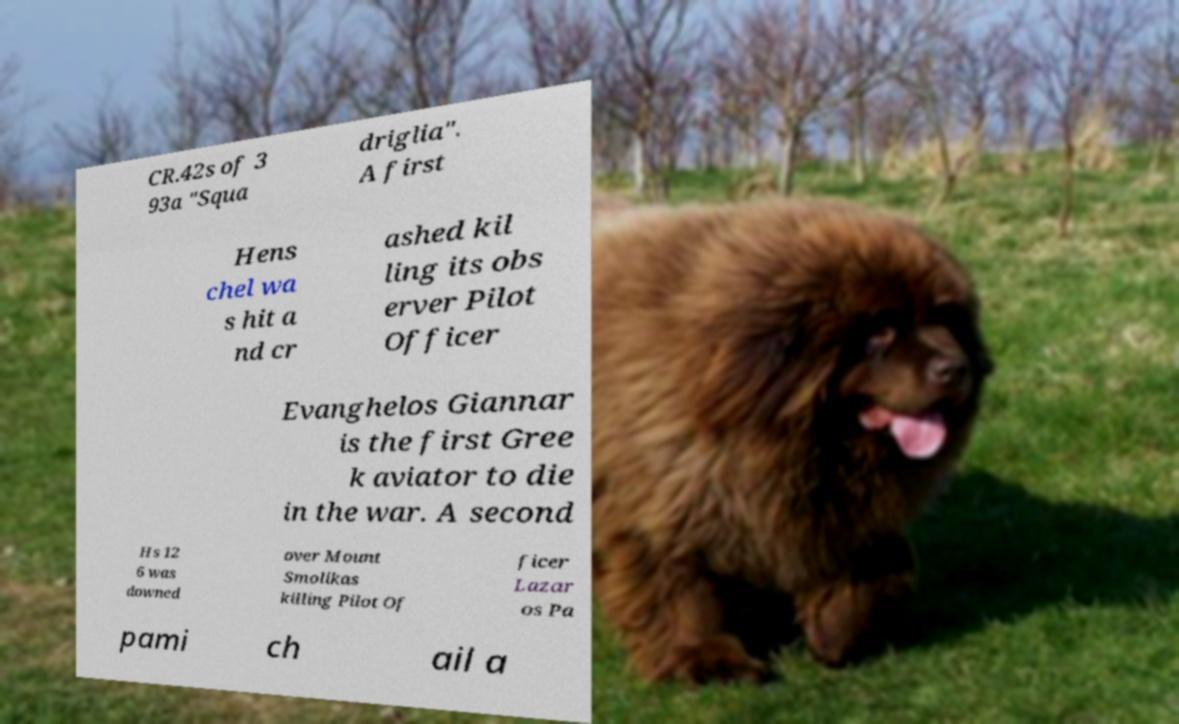There's text embedded in this image that I need extracted. Can you transcribe it verbatim? CR.42s of 3 93a "Squa driglia". A first Hens chel wa s hit a nd cr ashed kil ling its obs erver Pilot Officer Evanghelos Giannar is the first Gree k aviator to die in the war. A second Hs 12 6 was downed over Mount Smolikas killing Pilot Of ficer Lazar os Pa pami ch ail a 